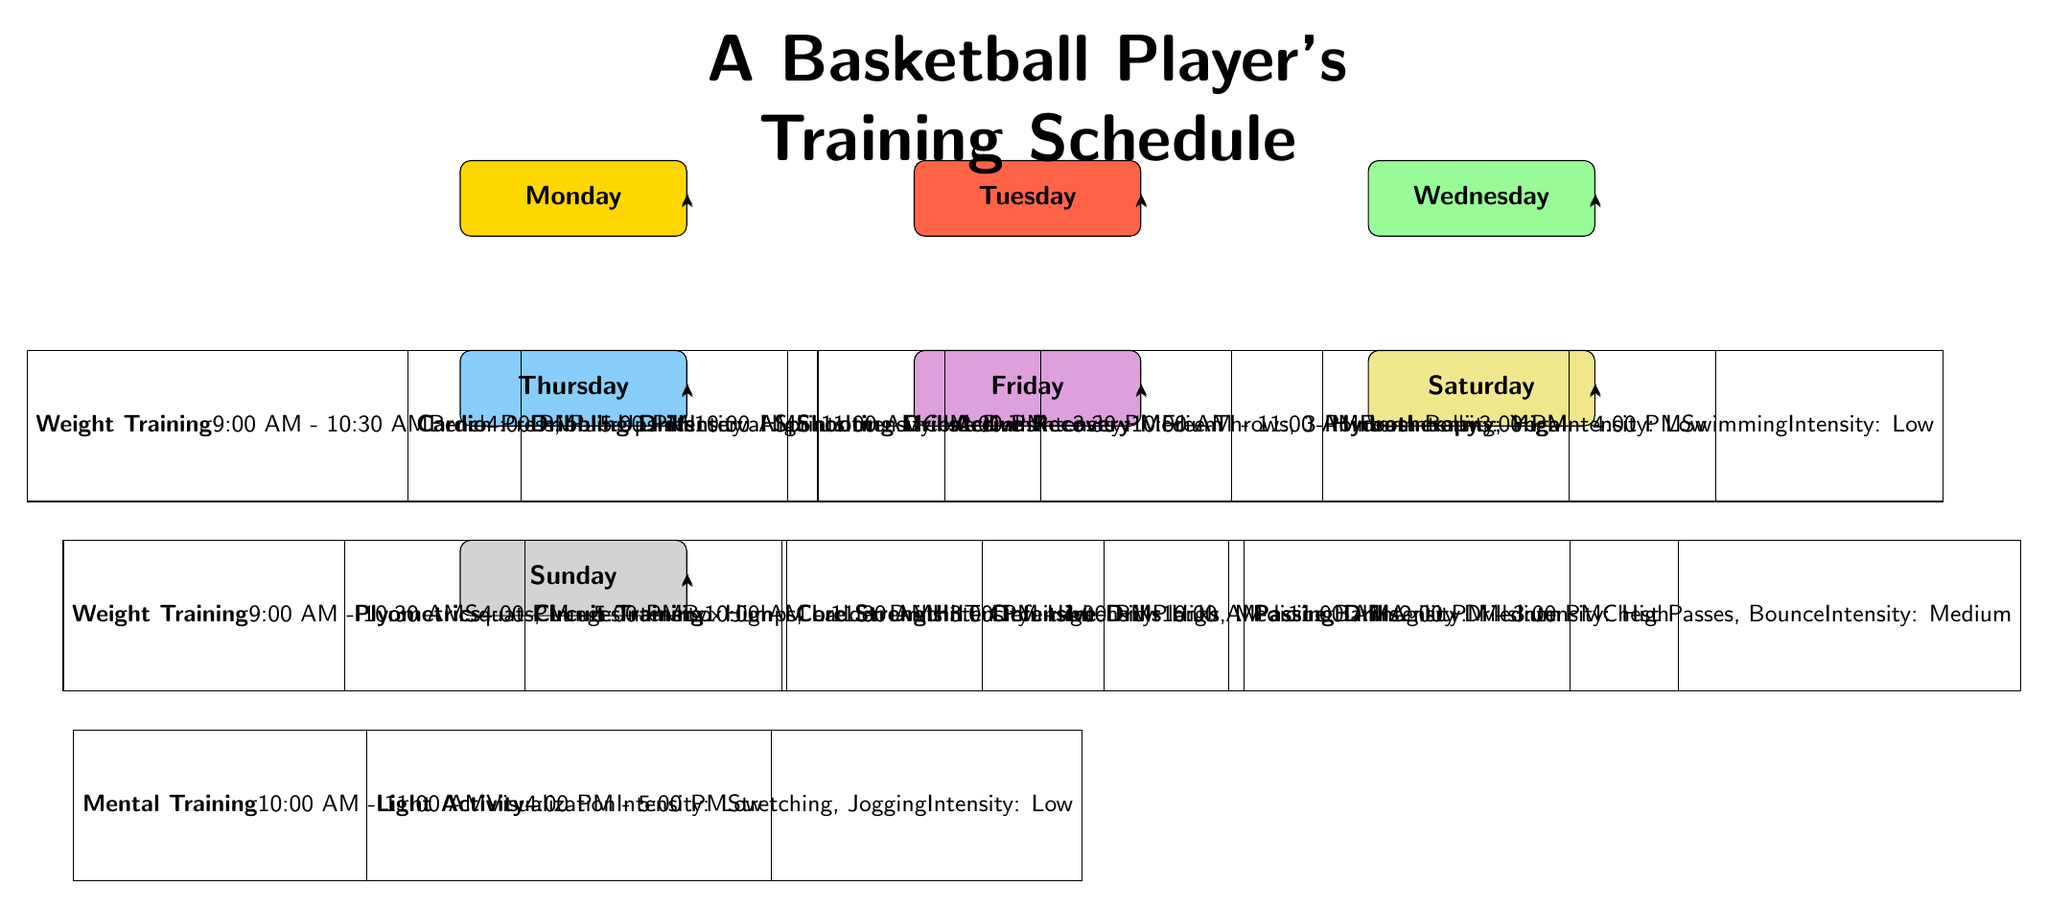What is the first training activity listed for Monday? The first training activity listed for Monday is Weight Training, which is indicated in the sub-node directly below the Monday main node.
Answer: Weight Training How long is the cardio session on Monday? The cardio session is scheduled from 4:00 PM to 5:00 PM, which is one hour long. This duration can be confirmed by calculating the time from the start to the end of the session given in the diagram.
Answer: One hour What is the intensity level of the shooting drills on Tuesday? The shooting drills are listed with an intensity level of High, as noted in the details provided in the sub-node under Tuesday.
Answer: High On which day does the player focus on Active Recovery? The day when the player focuses on Active Recovery is Wednesday, as indicated in the main node for that day, along with the specific training activity listed below it.
Answer: Wednesday How many training activities are scheduled on Saturday? There are two training activities scheduled on Saturday: Defensive Drills and Passing Drills. This is determined by counting the sub-nodes listed below the Saturday main node.
Answer: Two Which training session has the latest starting time on Thursday? The training session with the latest starting time on Thursday is Plyometrics, which starts at 4:00 PM. This can be identified by comparing the starting times of the two activities scheduled for that day.
Answer: Plyometrics What type of training is scheduled last on Sunday? The last type of training scheduled on Sunday is Light Activity, which occurs from 4:00 PM to 5:00 PM. This is inferred by looking at the sub-nodes for Sunday and noting the order and timing of listed activities.
Answer: Light Activity What color represents Tuesday in the diagram? Tuesday is represented in the diagram by the color Tomato, which can be confirmed by examining the fill color specified for the Tuesday node.
Answer: Tomato How many different types of training drills are there on Friday? On Friday, there are two different types of training drills listed: Circuit Training and Core Strength. This is determined by reviewing the two sub-nodes connected to the Friday main node.
Answer: Two 